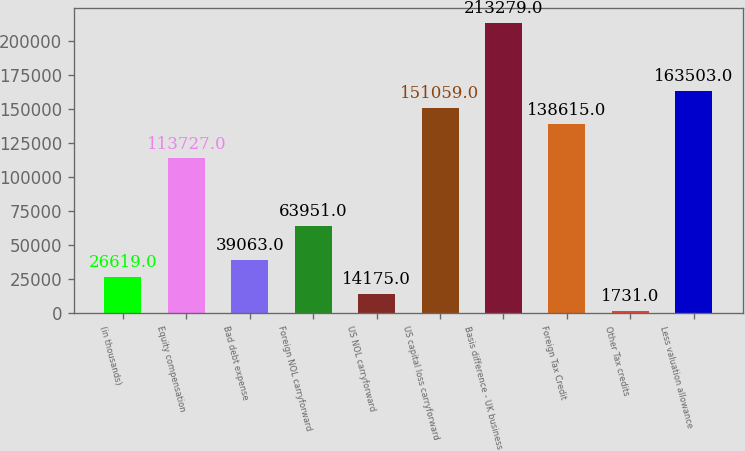Convert chart. <chart><loc_0><loc_0><loc_500><loc_500><bar_chart><fcel>(in thousands)<fcel>Equity compensation<fcel>Bad debt expense<fcel>Foreign NOL carryforward<fcel>US NOL carryforward<fcel>US capital loss carryforward<fcel>Basis difference - UK business<fcel>Foreign Tax Credit<fcel>Other Tax credits<fcel>Less valuation allowance<nl><fcel>26619<fcel>113727<fcel>39063<fcel>63951<fcel>14175<fcel>151059<fcel>213279<fcel>138615<fcel>1731<fcel>163503<nl></chart> 